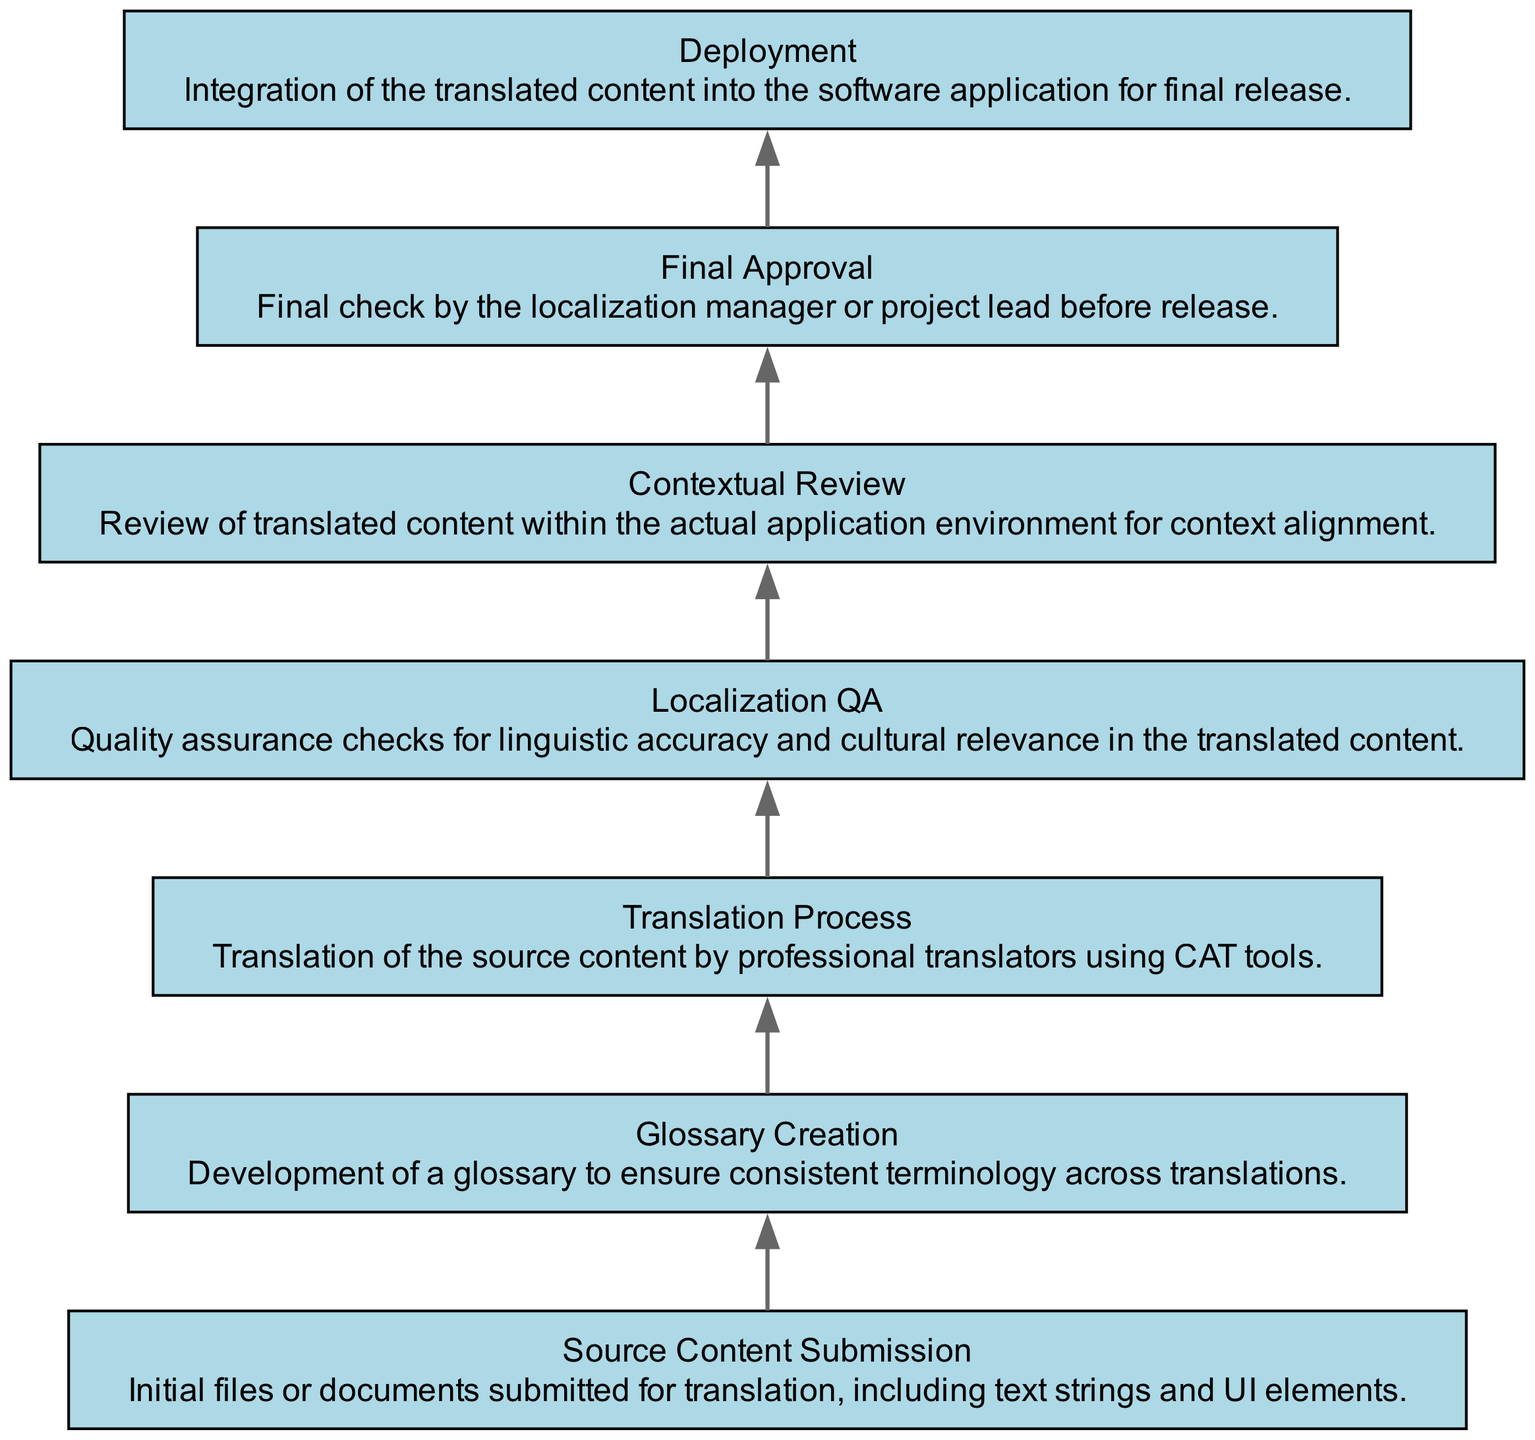What is the first stage in the localization workflow? The first stage is the node labeled "Source Content Submission," which indicates the beginning of the workflow where initial files or documents are submitted for translation.
Answer: Source Content Submission How many stages are involved in the localization workflow? The diagram contains a total of seven stages, as indicated by the seven nodes present within the workflow.
Answer: 7 What follows the "Glossary Creation" stage? After the "Glossary Creation" stage, the next stage is the "Translation Process," which indicates that translation is based on the created glossary.
Answer: Translation Process Which stage involves the final check before release? The stage that involves the final check before the release of the application is "Final Approval." This indicates that all content must be approved before deployment.
Answer: Final Approval What is the last step in the localization workflow? The last step in the workflow is "Deployment," which signifies the integration of the translated content into the software application for final release.
Answer: Deployment Which two stages involve checks for quality assurance? The two stages that involve checks for quality assurance are "Localization QA" and "Final Approval." Both stages are focused on ensuring the quality of the translation content.
Answer: Localization QA, Final Approval In what stage is linguistic accuracy checked? Linguistic accuracy is checked during the "Localization QA" stage, which specifically aims at quality assurance checks for linguistic and cultural adequacy.
Answer: Localization QA Identify a stage that requires contextual evaluation. The stage that requires contextual evaluation is "Contextual Review," where translated content is assessed in the actual application environment for alignment with the context.
Answer: Contextual Review What is the purpose of the "Glossary Creation" stage? The purpose of the "Glossary Creation" stage is to develop a glossary that ensures consistent terminology across translations, which helps maintain coherence in the content.
Answer: Consistent terminology 